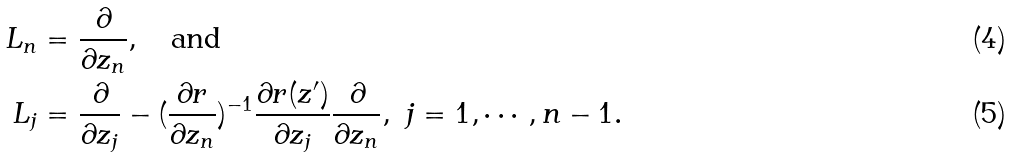<formula> <loc_0><loc_0><loc_500><loc_500>L _ { n } & = \frac { \partial } { \partial z _ { n } } , \quad \text {and} \\ L _ { j } & = \frac { \partial } { \partial z _ { j } } - ( \frac { \partial r } { \partial z _ { n } } ) ^ { - 1 } \frac { \partial r ( z ^ { \prime } ) } { \partial z _ { j } } \frac { \partial } { \partial z _ { n } } , \ j = 1 , \cdots , n - 1 .</formula> 